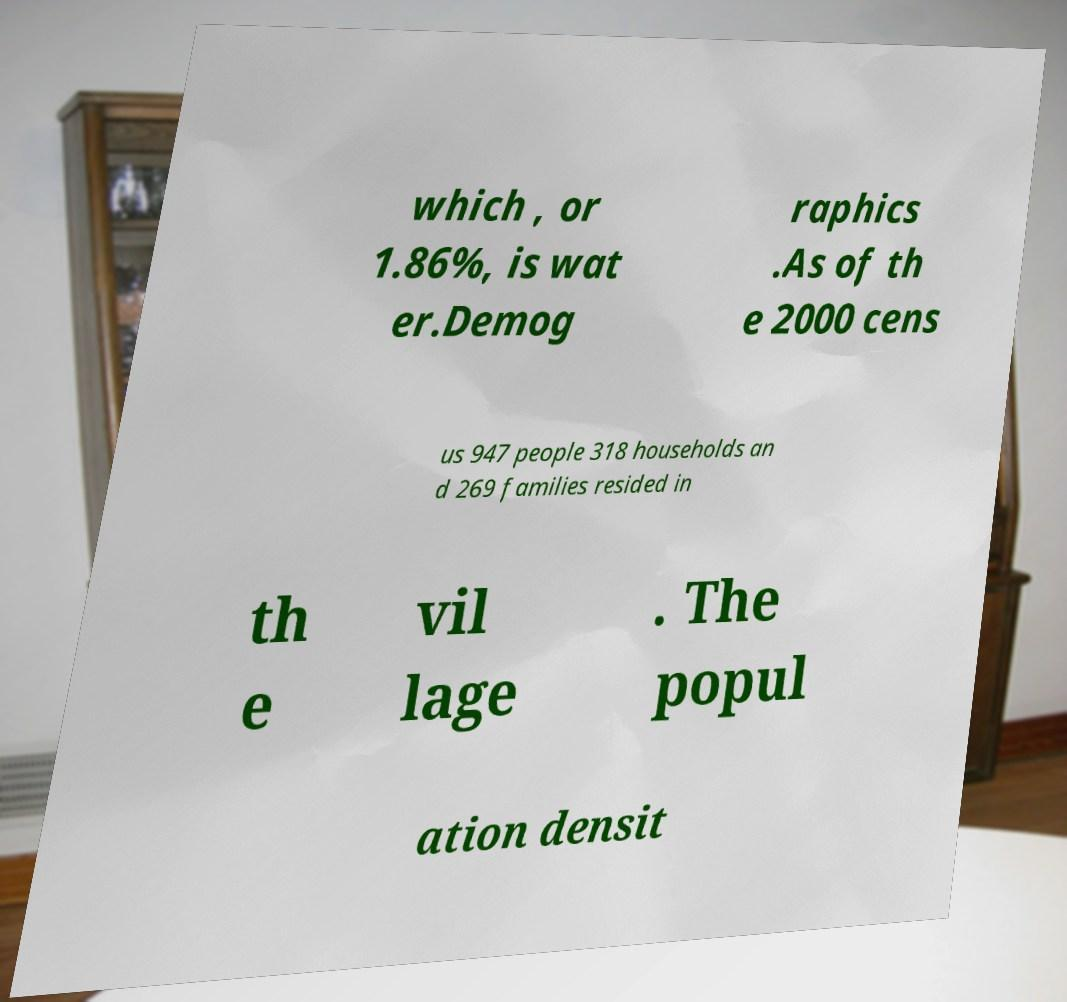Please identify and transcribe the text found in this image. which , or 1.86%, is wat er.Demog raphics .As of th e 2000 cens us 947 people 318 households an d 269 families resided in th e vil lage . The popul ation densit 